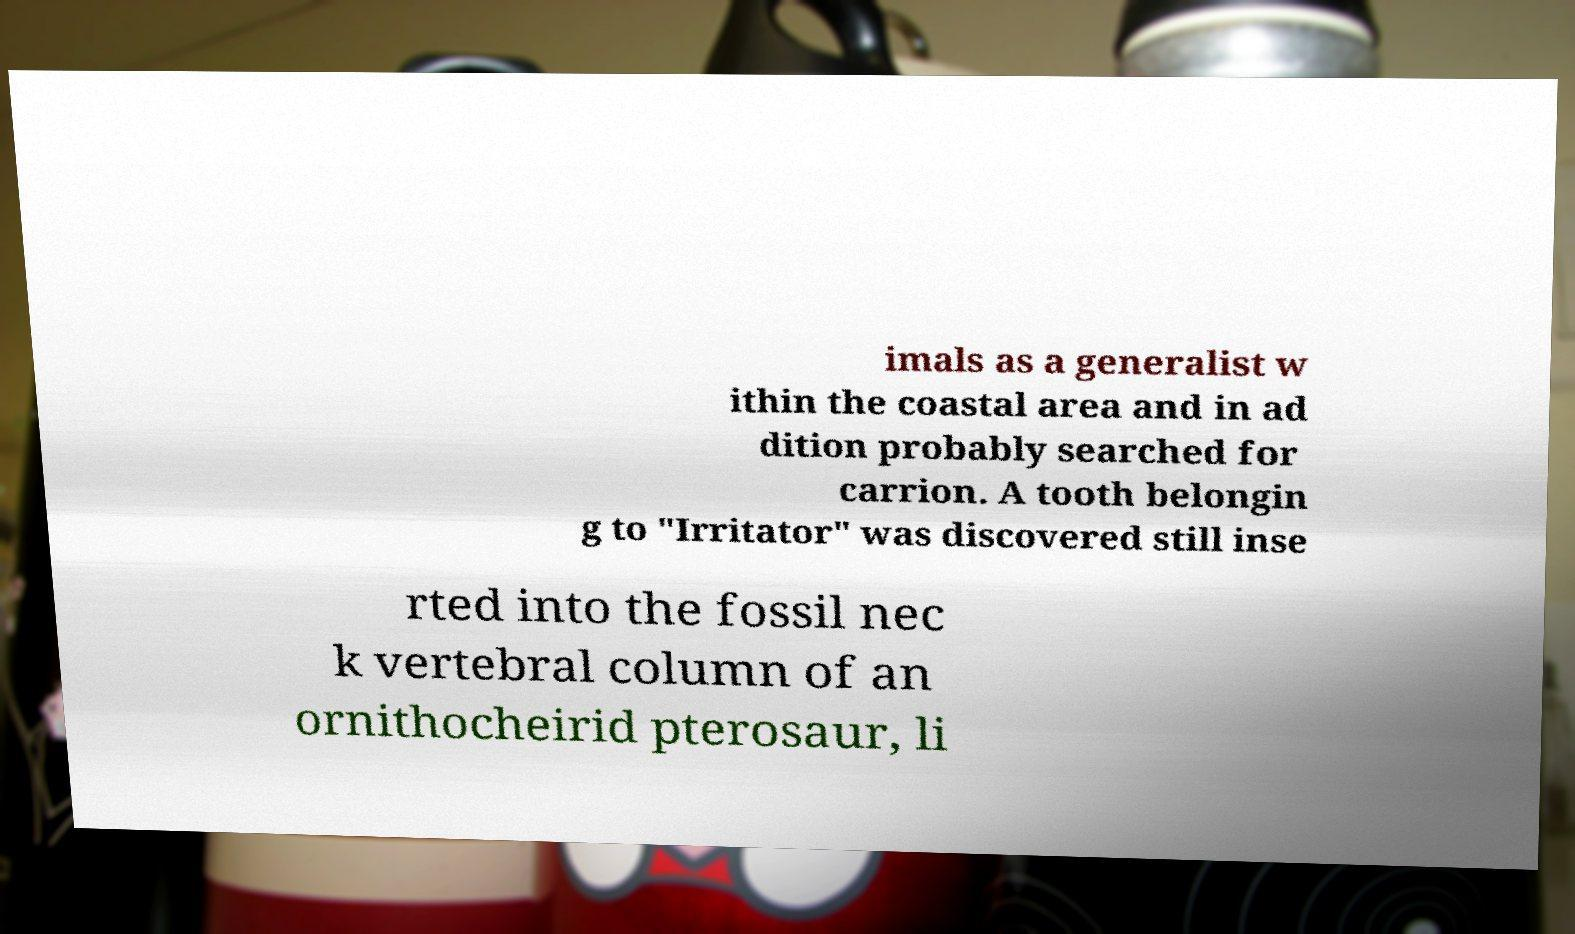There's text embedded in this image that I need extracted. Can you transcribe it verbatim? imals as a generalist w ithin the coastal area and in ad dition probably searched for carrion. A tooth belongin g to "Irritator" was discovered still inse rted into the fossil nec k vertebral column of an ornithocheirid pterosaur, li 